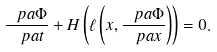Convert formula to latex. <formula><loc_0><loc_0><loc_500><loc_500>\frac { \ p a \Phi } { \ p a t } + H \left ( \ell \left ( x , \frac { \ p a \Phi } { \ p a x } \right ) \right ) = 0 .</formula> 